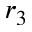Convert formula to latex. <formula><loc_0><loc_0><loc_500><loc_500>r _ { 3 }</formula> 